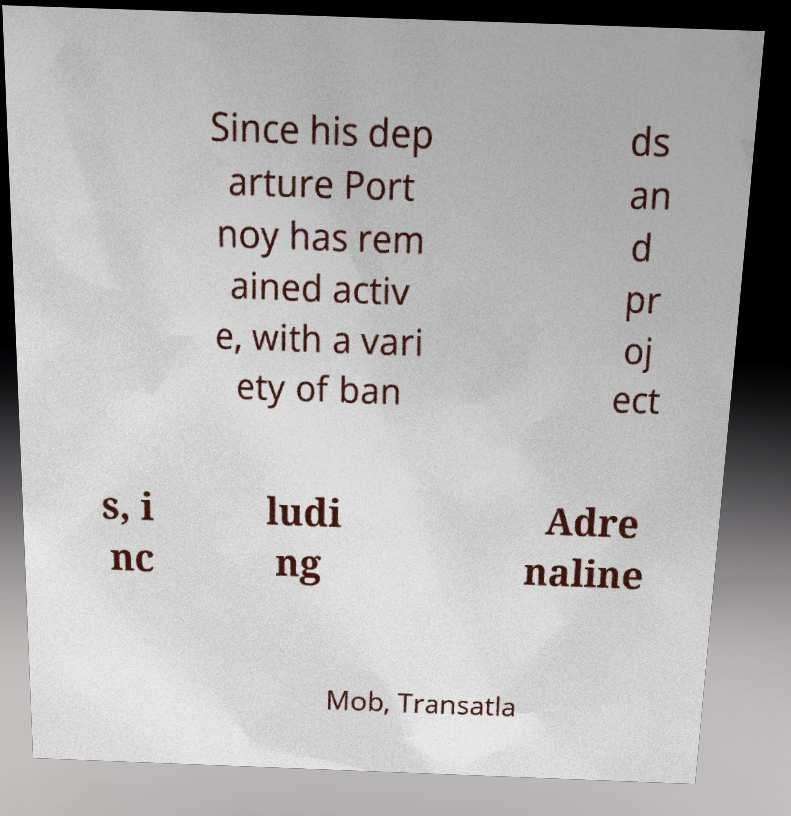Could you extract and type out the text from this image? Since his dep arture Port noy has rem ained activ e, with a vari ety of ban ds an d pr oj ect s, i nc ludi ng Adre naline Mob, Transatla 